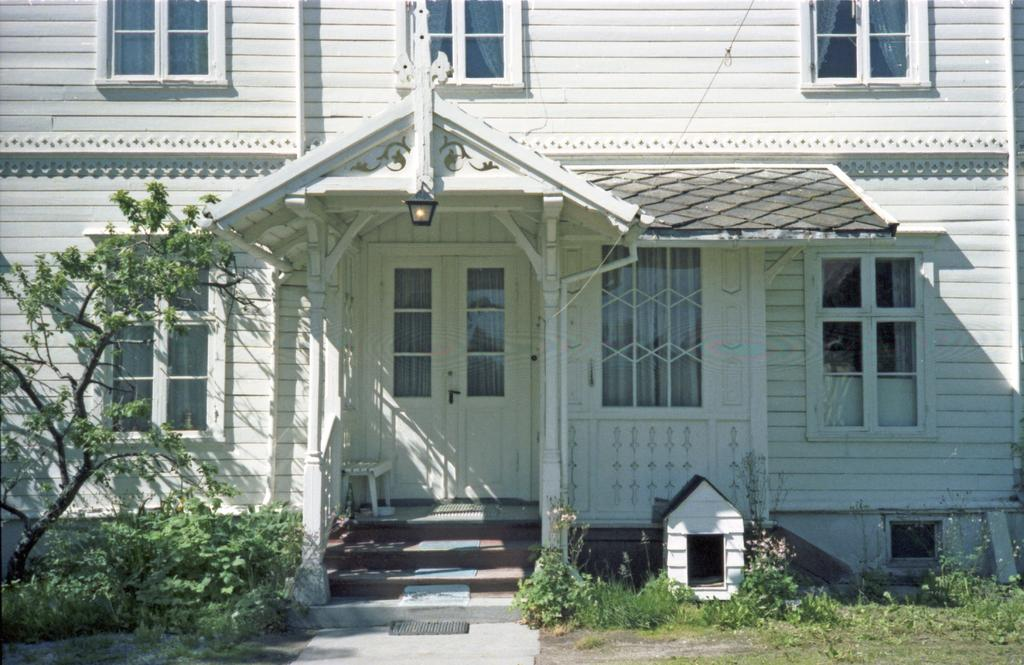What is in the foreground of the image? In the foreground of the image, there is a pavement, grass, plants, and a tree. Can you describe the house in the image? There is a house in the image, but the specific details of the house are not mentioned in the facts. What other structures are visible in the image? In addition to the house, there is a dog house in the image. What type of lighting is present in the image? There is a light in the image. How many snakes are slithering on the slope in the image? There are no snakes or slopes present in the image. What type of joke is being told by the dog house in the image? There is no joke being told by the dog house in the image, as it is an inanimate object. 